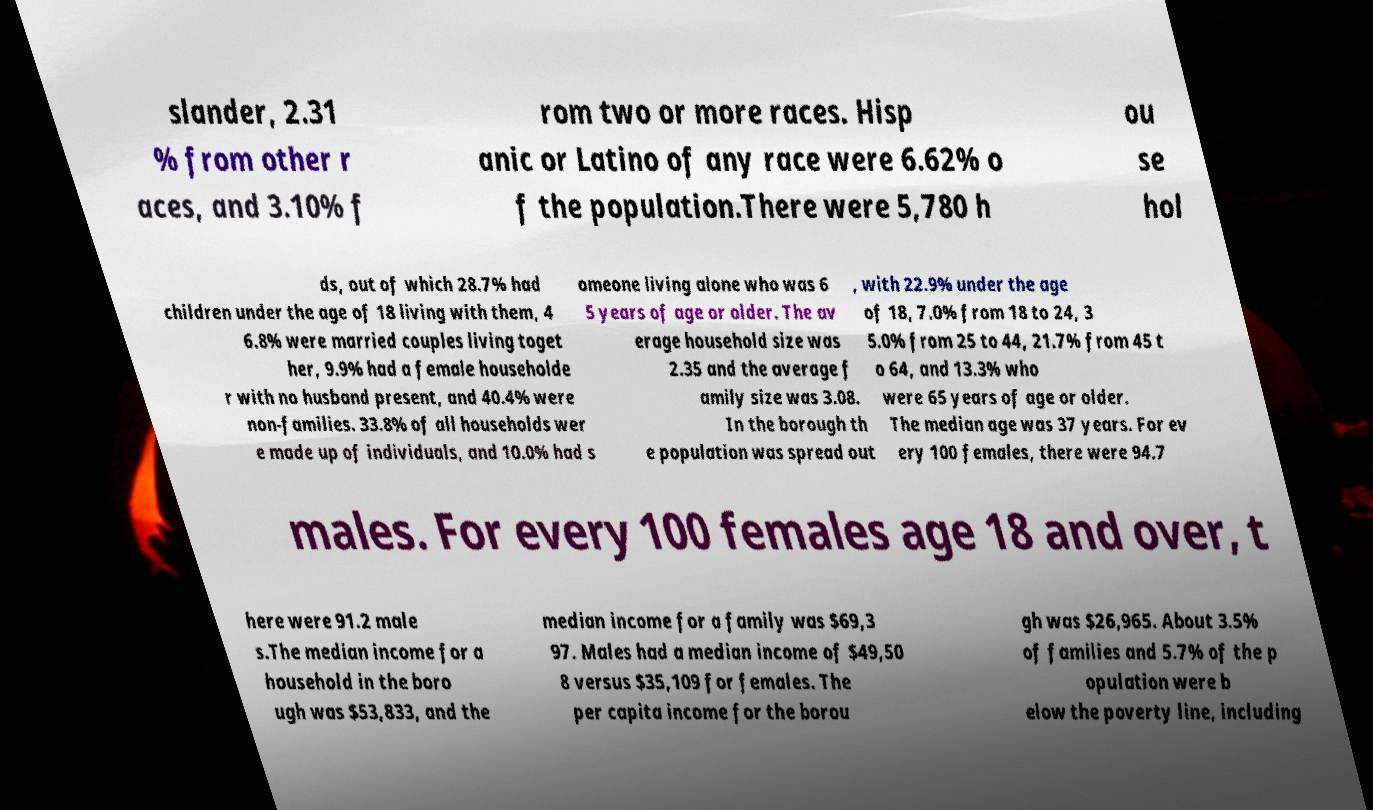For documentation purposes, I need the text within this image transcribed. Could you provide that? slander, 2.31 % from other r aces, and 3.10% f rom two or more races. Hisp anic or Latino of any race were 6.62% o f the population.There were 5,780 h ou se hol ds, out of which 28.7% had children under the age of 18 living with them, 4 6.8% were married couples living toget her, 9.9% had a female householde r with no husband present, and 40.4% were non-families. 33.8% of all households wer e made up of individuals, and 10.0% had s omeone living alone who was 6 5 years of age or older. The av erage household size was 2.35 and the average f amily size was 3.08. In the borough th e population was spread out , with 22.9% under the age of 18, 7.0% from 18 to 24, 3 5.0% from 25 to 44, 21.7% from 45 t o 64, and 13.3% who were 65 years of age or older. The median age was 37 years. For ev ery 100 females, there were 94.7 males. For every 100 females age 18 and over, t here were 91.2 male s.The median income for a household in the boro ugh was $53,833, and the median income for a family was $69,3 97. Males had a median income of $49,50 8 versus $35,109 for females. The per capita income for the borou gh was $26,965. About 3.5% of families and 5.7% of the p opulation were b elow the poverty line, including 